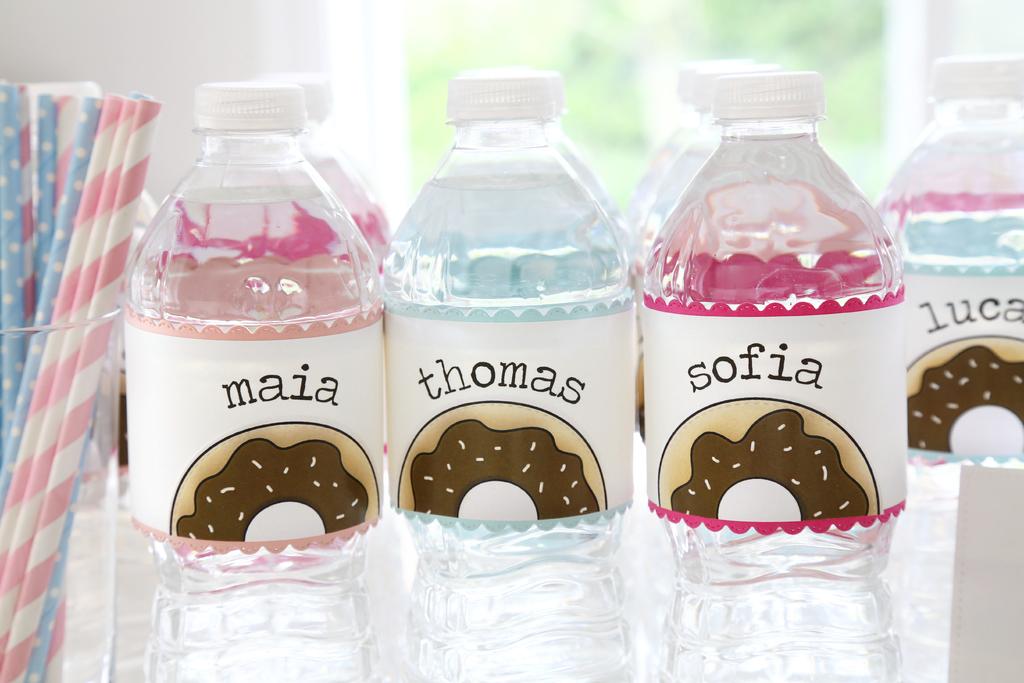Whose name is the boys in the middle?
Make the answer very short. Thomas. Whose name is on the left bottle?
Provide a succinct answer. Maia. 